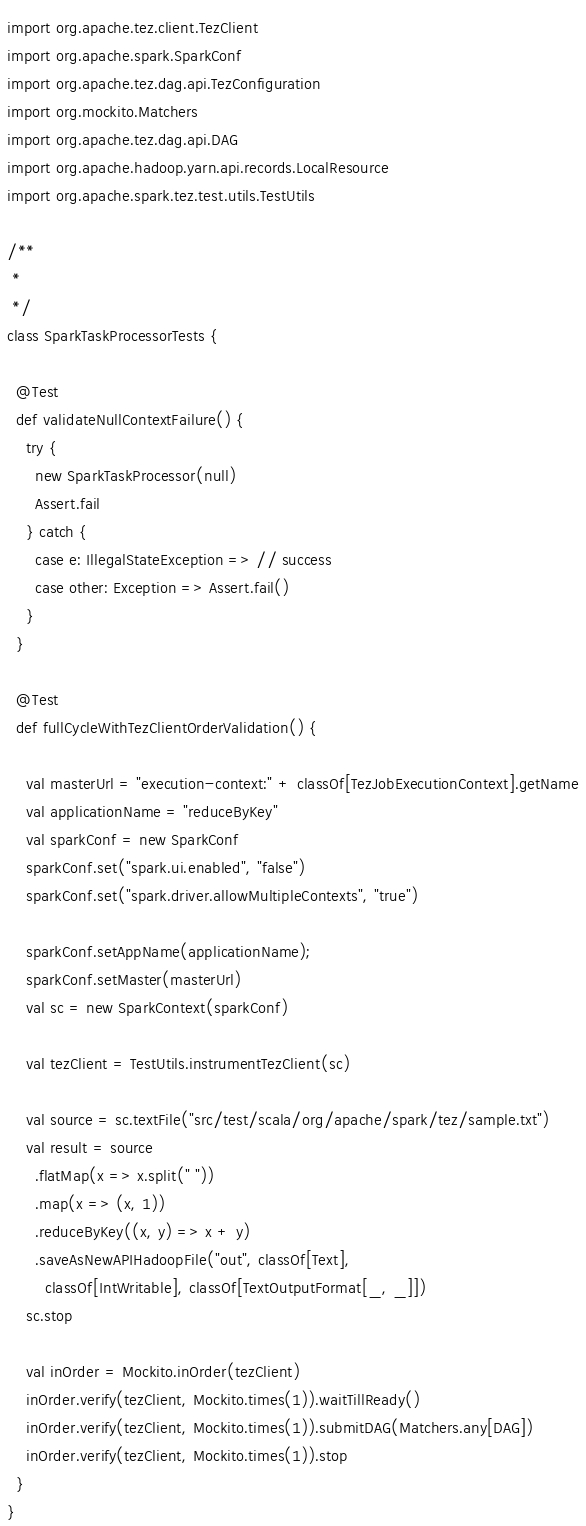Convert code to text. <code><loc_0><loc_0><loc_500><loc_500><_Scala_>import org.apache.tez.client.TezClient
import org.apache.spark.SparkConf
import org.apache.tez.dag.api.TezConfiguration
import org.mockito.Matchers
import org.apache.tez.dag.api.DAG
import org.apache.hadoop.yarn.api.records.LocalResource
import org.apache.spark.tez.test.utils.TestUtils

/**
 *
 */
class SparkTaskProcessorTests {

  @Test
  def validateNullContextFailure() {
    try {
      new SparkTaskProcessor(null)
      Assert.fail
    } catch {
      case e: IllegalStateException => // success
      case other: Exception => Assert.fail()
    }
  }

  @Test
  def fullCycleWithTezClientOrderValidation() {

    val masterUrl = "execution-context:" + classOf[TezJobExecutionContext].getName
    val applicationName = "reduceByKey"
    val sparkConf = new SparkConf
    sparkConf.set("spark.ui.enabled", "false")
    sparkConf.set("spark.driver.allowMultipleContexts", "true")
    
    sparkConf.setAppName(applicationName);
    sparkConf.setMaster(masterUrl)
    val sc = new SparkContext(sparkConf)

    val tezClient = TestUtils.instrumentTezClient(sc)

    val source = sc.textFile("src/test/scala/org/apache/spark/tez/sample.txt")
    val result = source
      .flatMap(x => x.split(" "))
      .map(x => (x, 1))
      .reduceByKey((x, y) => x + y)
      .saveAsNewAPIHadoopFile("out", classOf[Text],
        classOf[IntWritable], classOf[TextOutputFormat[_, _]])
    sc.stop
    
    val inOrder = Mockito.inOrder(tezClient)
    inOrder.verify(tezClient, Mockito.times(1)).waitTillReady()
    inOrder.verify(tezClient, Mockito.times(1)).submitDAG(Matchers.any[DAG])
    inOrder.verify(tezClient, Mockito.times(1)).stop
  }
}</code> 